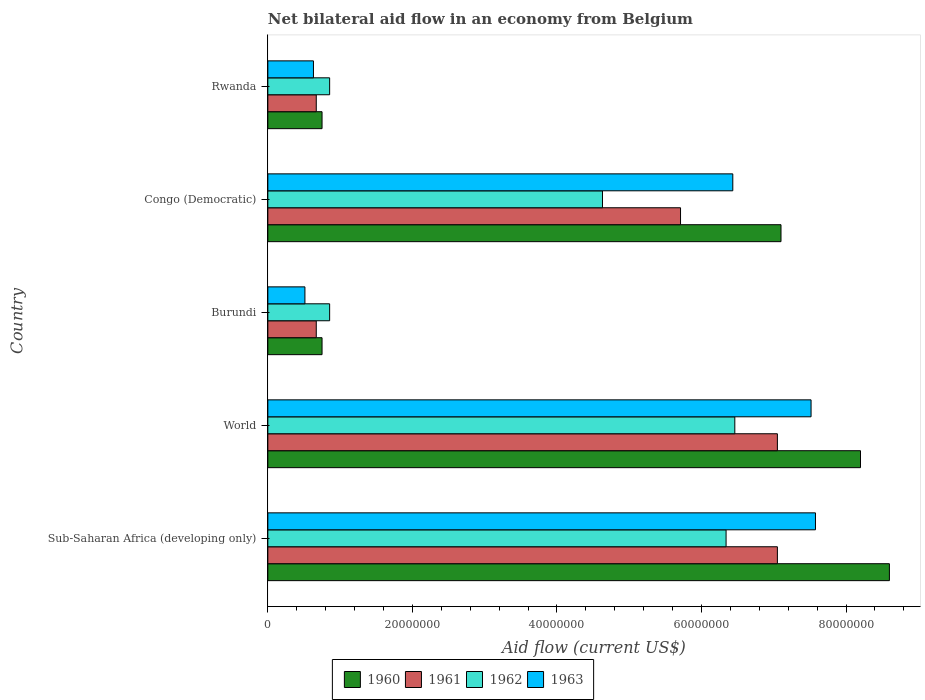How many different coloured bars are there?
Your answer should be compact. 4. How many groups of bars are there?
Keep it short and to the point. 5. How many bars are there on the 3rd tick from the top?
Your response must be concise. 4. How many bars are there on the 3rd tick from the bottom?
Provide a succinct answer. 4. What is the label of the 3rd group of bars from the top?
Your response must be concise. Burundi. In how many cases, is the number of bars for a given country not equal to the number of legend labels?
Your answer should be very brief. 0. What is the net bilateral aid flow in 1960 in Burundi?
Keep it short and to the point. 7.50e+06. Across all countries, what is the maximum net bilateral aid flow in 1961?
Keep it short and to the point. 7.05e+07. Across all countries, what is the minimum net bilateral aid flow in 1962?
Give a very brief answer. 8.55e+06. In which country was the net bilateral aid flow in 1963 maximum?
Your answer should be very brief. Sub-Saharan Africa (developing only). In which country was the net bilateral aid flow in 1961 minimum?
Keep it short and to the point. Burundi. What is the total net bilateral aid flow in 1963 in the graph?
Give a very brief answer. 2.27e+08. What is the difference between the net bilateral aid flow in 1961 in Congo (Democratic) and that in World?
Make the answer very short. -1.34e+07. What is the difference between the net bilateral aid flow in 1962 in Congo (Democratic) and the net bilateral aid flow in 1961 in World?
Make the answer very short. -2.42e+07. What is the average net bilateral aid flow in 1961 per country?
Ensure brevity in your answer.  4.23e+07. What is the difference between the net bilateral aid flow in 1962 and net bilateral aid flow in 1963 in World?
Make the answer very short. -1.06e+07. What is the ratio of the net bilateral aid flow in 1962 in Rwanda to that in World?
Offer a very short reply. 0.13. Is the net bilateral aid flow in 1961 in Burundi less than that in Congo (Democratic)?
Your response must be concise. Yes. Is the difference between the net bilateral aid flow in 1962 in Burundi and Sub-Saharan Africa (developing only) greater than the difference between the net bilateral aid flow in 1963 in Burundi and Sub-Saharan Africa (developing only)?
Ensure brevity in your answer.  Yes. What is the difference between the highest and the second highest net bilateral aid flow in 1960?
Offer a very short reply. 4.00e+06. What is the difference between the highest and the lowest net bilateral aid flow in 1960?
Provide a short and direct response. 7.85e+07. In how many countries, is the net bilateral aid flow in 1962 greater than the average net bilateral aid flow in 1962 taken over all countries?
Give a very brief answer. 3. Is it the case that in every country, the sum of the net bilateral aid flow in 1963 and net bilateral aid flow in 1960 is greater than the sum of net bilateral aid flow in 1961 and net bilateral aid flow in 1962?
Offer a terse response. No. What does the 4th bar from the top in Rwanda represents?
Your answer should be very brief. 1960. Is it the case that in every country, the sum of the net bilateral aid flow in 1962 and net bilateral aid flow in 1960 is greater than the net bilateral aid flow in 1963?
Your answer should be compact. Yes. How many bars are there?
Provide a short and direct response. 20. What is the difference between two consecutive major ticks on the X-axis?
Give a very brief answer. 2.00e+07. Are the values on the major ticks of X-axis written in scientific E-notation?
Offer a very short reply. No. What is the title of the graph?
Keep it short and to the point. Net bilateral aid flow in an economy from Belgium. Does "2010" appear as one of the legend labels in the graph?
Offer a terse response. No. What is the label or title of the Y-axis?
Your answer should be compact. Country. What is the Aid flow (current US$) of 1960 in Sub-Saharan Africa (developing only)?
Make the answer very short. 8.60e+07. What is the Aid flow (current US$) in 1961 in Sub-Saharan Africa (developing only)?
Make the answer very short. 7.05e+07. What is the Aid flow (current US$) in 1962 in Sub-Saharan Africa (developing only)?
Provide a short and direct response. 6.34e+07. What is the Aid flow (current US$) of 1963 in Sub-Saharan Africa (developing only)?
Your answer should be very brief. 7.58e+07. What is the Aid flow (current US$) in 1960 in World?
Provide a succinct answer. 8.20e+07. What is the Aid flow (current US$) in 1961 in World?
Make the answer very short. 7.05e+07. What is the Aid flow (current US$) in 1962 in World?
Give a very brief answer. 6.46e+07. What is the Aid flow (current US$) in 1963 in World?
Provide a short and direct response. 7.52e+07. What is the Aid flow (current US$) in 1960 in Burundi?
Provide a short and direct response. 7.50e+06. What is the Aid flow (current US$) of 1961 in Burundi?
Your response must be concise. 6.70e+06. What is the Aid flow (current US$) in 1962 in Burundi?
Keep it short and to the point. 8.55e+06. What is the Aid flow (current US$) in 1963 in Burundi?
Ensure brevity in your answer.  5.13e+06. What is the Aid flow (current US$) in 1960 in Congo (Democratic)?
Your response must be concise. 7.10e+07. What is the Aid flow (current US$) of 1961 in Congo (Democratic)?
Your response must be concise. 5.71e+07. What is the Aid flow (current US$) in 1962 in Congo (Democratic)?
Provide a succinct answer. 4.63e+07. What is the Aid flow (current US$) in 1963 in Congo (Democratic)?
Offer a terse response. 6.43e+07. What is the Aid flow (current US$) in 1960 in Rwanda?
Provide a succinct answer. 7.50e+06. What is the Aid flow (current US$) in 1961 in Rwanda?
Provide a short and direct response. 6.70e+06. What is the Aid flow (current US$) of 1962 in Rwanda?
Your answer should be compact. 8.55e+06. What is the Aid flow (current US$) of 1963 in Rwanda?
Provide a short and direct response. 6.31e+06. Across all countries, what is the maximum Aid flow (current US$) of 1960?
Your answer should be compact. 8.60e+07. Across all countries, what is the maximum Aid flow (current US$) of 1961?
Offer a terse response. 7.05e+07. Across all countries, what is the maximum Aid flow (current US$) in 1962?
Your answer should be compact. 6.46e+07. Across all countries, what is the maximum Aid flow (current US$) in 1963?
Make the answer very short. 7.58e+07. Across all countries, what is the minimum Aid flow (current US$) in 1960?
Your answer should be very brief. 7.50e+06. Across all countries, what is the minimum Aid flow (current US$) in 1961?
Give a very brief answer. 6.70e+06. Across all countries, what is the minimum Aid flow (current US$) of 1962?
Ensure brevity in your answer.  8.55e+06. Across all countries, what is the minimum Aid flow (current US$) in 1963?
Your response must be concise. 5.13e+06. What is the total Aid flow (current US$) of 1960 in the graph?
Give a very brief answer. 2.54e+08. What is the total Aid flow (current US$) of 1961 in the graph?
Offer a very short reply. 2.12e+08. What is the total Aid flow (current US$) of 1962 in the graph?
Provide a succinct answer. 1.91e+08. What is the total Aid flow (current US$) in 1963 in the graph?
Your answer should be compact. 2.27e+08. What is the difference between the Aid flow (current US$) of 1960 in Sub-Saharan Africa (developing only) and that in World?
Your response must be concise. 4.00e+06. What is the difference between the Aid flow (current US$) in 1962 in Sub-Saharan Africa (developing only) and that in World?
Keep it short and to the point. -1.21e+06. What is the difference between the Aid flow (current US$) in 1963 in Sub-Saharan Africa (developing only) and that in World?
Ensure brevity in your answer.  6.10e+05. What is the difference between the Aid flow (current US$) in 1960 in Sub-Saharan Africa (developing only) and that in Burundi?
Give a very brief answer. 7.85e+07. What is the difference between the Aid flow (current US$) of 1961 in Sub-Saharan Africa (developing only) and that in Burundi?
Offer a terse response. 6.38e+07. What is the difference between the Aid flow (current US$) in 1962 in Sub-Saharan Africa (developing only) and that in Burundi?
Provide a succinct answer. 5.48e+07. What is the difference between the Aid flow (current US$) in 1963 in Sub-Saharan Africa (developing only) and that in Burundi?
Offer a very short reply. 7.06e+07. What is the difference between the Aid flow (current US$) in 1960 in Sub-Saharan Africa (developing only) and that in Congo (Democratic)?
Ensure brevity in your answer.  1.50e+07. What is the difference between the Aid flow (current US$) of 1961 in Sub-Saharan Africa (developing only) and that in Congo (Democratic)?
Provide a short and direct response. 1.34e+07. What is the difference between the Aid flow (current US$) of 1962 in Sub-Saharan Africa (developing only) and that in Congo (Democratic)?
Your answer should be very brief. 1.71e+07. What is the difference between the Aid flow (current US$) in 1963 in Sub-Saharan Africa (developing only) and that in Congo (Democratic)?
Your answer should be compact. 1.14e+07. What is the difference between the Aid flow (current US$) in 1960 in Sub-Saharan Africa (developing only) and that in Rwanda?
Offer a terse response. 7.85e+07. What is the difference between the Aid flow (current US$) of 1961 in Sub-Saharan Africa (developing only) and that in Rwanda?
Your answer should be compact. 6.38e+07. What is the difference between the Aid flow (current US$) in 1962 in Sub-Saharan Africa (developing only) and that in Rwanda?
Provide a short and direct response. 5.48e+07. What is the difference between the Aid flow (current US$) of 1963 in Sub-Saharan Africa (developing only) and that in Rwanda?
Ensure brevity in your answer.  6.95e+07. What is the difference between the Aid flow (current US$) in 1960 in World and that in Burundi?
Offer a terse response. 7.45e+07. What is the difference between the Aid flow (current US$) of 1961 in World and that in Burundi?
Give a very brief answer. 6.38e+07. What is the difference between the Aid flow (current US$) in 1962 in World and that in Burundi?
Keep it short and to the point. 5.61e+07. What is the difference between the Aid flow (current US$) in 1963 in World and that in Burundi?
Your response must be concise. 7.00e+07. What is the difference between the Aid flow (current US$) in 1960 in World and that in Congo (Democratic)?
Give a very brief answer. 1.10e+07. What is the difference between the Aid flow (current US$) of 1961 in World and that in Congo (Democratic)?
Make the answer very short. 1.34e+07. What is the difference between the Aid flow (current US$) in 1962 in World and that in Congo (Democratic)?
Offer a terse response. 1.83e+07. What is the difference between the Aid flow (current US$) of 1963 in World and that in Congo (Democratic)?
Make the answer very short. 1.08e+07. What is the difference between the Aid flow (current US$) of 1960 in World and that in Rwanda?
Your answer should be very brief. 7.45e+07. What is the difference between the Aid flow (current US$) in 1961 in World and that in Rwanda?
Ensure brevity in your answer.  6.38e+07. What is the difference between the Aid flow (current US$) of 1962 in World and that in Rwanda?
Keep it short and to the point. 5.61e+07. What is the difference between the Aid flow (current US$) in 1963 in World and that in Rwanda?
Offer a very short reply. 6.88e+07. What is the difference between the Aid flow (current US$) in 1960 in Burundi and that in Congo (Democratic)?
Your response must be concise. -6.35e+07. What is the difference between the Aid flow (current US$) of 1961 in Burundi and that in Congo (Democratic)?
Offer a terse response. -5.04e+07. What is the difference between the Aid flow (current US$) of 1962 in Burundi and that in Congo (Democratic)?
Provide a short and direct response. -3.78e+07. What is the difference between the Aid flow (current US$) in 1963 in Burundi and that in Congo (Democratic)?
Give a very brief answer. -5.92e+07. What is the difference between the Aid flow (current US$) of 1961 in Burundi and that in Rwanda?
Offer a very short reply. 0. What is the difference between the Aid flow (current US$) of 1963 in Burundi and that in Rwanda?
Your response must be concise. -1.18e+06. What is the difference between the Aid flow (current US$) in 1960 in Congo (Democratic) and that in Rwanda?
Offer a terse response. 6.35e+07. What is the difference between the Aid flow (current US$) in 1961 in Congo (Democratic) and that in Rwanda?
Offer a very short reply. 5.04e+07. What is the difference between the Aid flow (current US$) of 1962 in Congo (Democratic) and that in Rwanda?
Provide a short and direct response. 3.78e+07. What is the difference between the Aid flow (current US$) of 1963 in Congo (Democratic) and that in Rwanda?
Offer a very short reply. 5.80e+07. What is the difference between the Aid flow (current US$) of 1960 in Sub-Saharan Africa (developing only) and the Aid flow (current US$) of 1961 in World?
Make the answer very short. 1.55e+07. What is the difference between the Aid flow (current US$) in 1960 in Sub-Saharan Africa (developing only) and the Aid flow (current US$) in 1962 in World?
Your response must be concise. 2.14e+07. What is the difference between the Aid flow (current US$) in 1960 in Sub-Saharan Africa (developing only) and the Aid flow (current US$) in 1963 in World?
Your answer should be compact. 1.08e+07. What is the difference between the Aid flow (current US$) in 1961 in Sub-Saharan Africa (developing only) and the Aid flow (current US$) in 1962 in World?
Offer a terse response. 5.89e+06. What is the difference between the Aid flow (current US$) of 1961 in Sub-Saharan Africa (developing only) and the Aid flow (current US$) of 1963 in World?
Your answer should be compact. -4.66e+06. What is the difference between the Aid flow (current US$) in 1962 in Sub-Saharan Africa (developing only) and the Aid flow (current US$) in 1963 in World?
Your answer should be very brief. -1.18e+07. What is the difference between the Aid flow (current US$) of 1960 in Sub-Saharan Africa (developing only) and the Aid flow (current US$) of 1961 in Burundi?
Your answer should be compact. 7.93e+07. What is the difference between the Aid flow (current US$) of 1960 in Sub-Saharan Africa (developing only) and the Aid flow (current US$) of 1962 in Burundi?
Your response must be concise. 7.74e+07. What is the difference between the Aid flow (current US$) of 1960 in Sub-Saharan Africa (developing only) and the Aid flow (current US$) of 1963 in Burundi?
Keep it short and to the point. 8.09e+07. What is the difference between the Aid flow (current US$) in 1961 in Sub-Saharan Africa (developing only) and the Aid flow (current US$) in 1962 in Burundi?
Make the answer very short. 6.20e+07. What is the difference between the Aid flow (current US$) in 1961 in Sub-Saharan Africa (developing only) and the Aid flow (current US$) in 1963 in Burundi?
Offer a very short reply. 6.54e+07. What is the difference between the Aid flow (current US$) of 1962 in Sub-Saharan Africa (developing only) and the Aid flow (current US$) of 1963 in Burundi?
Offer a terse response. 5.83e+07. What is the difference between the Aid flow (current US$) of 1960 in Sub-Saharan Africa (developing only) and the Aid flow (current US$) of 1961 in Congo (Democratic)?
Offer a terse response. 2.89e+07. What is the difference between the Aid flow (current US$) of 1960 in Sub-Saharan Africa (developing only) and the Aid flow (current US$) of 1962 in Congo (Democratic)?
Your answer should be very brief. 3.97e+07. What is the difference between the Aid flow (current US$) in 1960 in Sub-Saharan Africa (developing only) and the Aid flow (current US$) in 1963 in Congo (Democratic)?
Keep it short and to the point. 2.17e+07. What is the difference between the Aid flow (current US$) in 1961 in Sub-Saharan Africa (developing only) and the Aid flow (current US$) in 1962 in Congo (Democratic)?
Offer a terse response. 2.42e+07. What is the difference between the Aid flow (current US$) in 1961 in Sub-Saharan Africa (developing only) and the Aid flow (current US$) in 1963 in Congo (Democratic)?
Make the answer very short. 6.17e+06. What is the difference between the Aid flow (current US$) in 1962 in Sub-Saharan Africa (developing only) and the Aid flow (current US$) in 1963 in Congo (Democratic)?
Offer a very short reply. -9.30e+05. What is the difference between the Aid flow (current US$) in 1960 in Sub-Saharan Africa (developing only) and the Aid flow (current US$) in 1961 in Rwanda?
Your response must be concise. 7.93e+07. What is the difference between the Aid flow (current US$) in 1960 in Sub-Saharan Africa (developing only) and the Aid flow (current US$) in 1962 in Rwanda?
Your answer should be compact. 7.74e+07. What is the difference between the Aid flow (current US$) in 1960 in Sub-Saharan Africa (developing only) and the Aid flow (current US$) in 1963 in Rwanda?
Your answer should be compact. 7.97e+07. What is the difference between the Aid flow (current US$) of 1961 in Sub-Saharan Africa (developing only) and the Aid flow (current US$) of 1962 in Rwanda?
Make the answer very short. 6.20e+07. What is the difference between the Aid flow (current US$) in 1961 in Sub-Saharan Africa (developing only) and the Aid flow (current US$) in 1963 in Rwanda?
Offer a terse response. 6.42e+07. What is the difference between the Aid flow (current US$) in 1962 in Sub-Saharan Africa (developing only) and the Aid flow (current US$) in 1963 in Rwanda?
Your answer should be compact. 5.71e+07. What is the difference between the Aid flow (current US$) of 1960 in World and the Aid flow (current US$) of 1961 in Burundi?
Your response must be concise. 7.53e+07. What is the difference between the Aid flow (current US$) in 1960 in World and the Aid flow (current US$) in 1962 in Burundi?
Provide a succinct answer. 7.34e+07. What is the difference between the Aid flow (current US$) of 1960 in World and the Aid flow (current US$) of 1963 in Burundi?
Keep it short and to the point. 7.69e+07. What is the difference between the Aid flow (current US$) of 1961 in World and the Aid flow (current US$) of 1962 in Burundi?
Offer a very short reply. 6.20e+07. What is the difference between the Aid flow (current US$) in 1961 in World and the Aid flow (current US$) in 1963 in Burundi?
Provide a short and direct response. 6.54e+07. What is the difference between the Aid flow (current US$) in 1962 in World and the Aid flow (current US$) in 1963 in Burundi?
Provide a succinct answer. 5.95e+07. What is the difference between the Aid flow (current US$) of 1960 in World and the Aid flow (current US$) of 1961 in Congo (Democratic)?
Offer a very short reply. 2.49e+07. What is the difference between the Aid flow (current US$) in 1960 in World and the Aid flow (current US$) in 1962 in Congo (Democratic)?
Ensure brevity in your answer.  3.57e+07. What is the difference between the Aid flow (current US$) of 1960 in World and the Aid flow (current US$) of 1963 in Congo (Democratic)?
Ensure brevity in your answer.  1.77e+07. What is the difference between the Aid flow (current US$) of 1961 in World and the Aid flow (current US$) of 1962 in Congo (Democratic)?
Ensure brevity in your answer.  2.42e+07. What is the difference between the Aid flow (current US$) in 1961 in World and the Aid flow (current US$) in 1963 in Congo (Democratic)?
Give a very brief answer. 6.17e+06. What is the difference between the Aid flow (current US$) of 1960 in World and the Aid flow (current US$) of 1961 in Rwanda?
Keep it short and to the point. 7.53e+07. What is the difference between the Aid flow (current US$) in 1960 in World and the Aid flow (current US$) in 1962 in Rwanda?
Your answer should be very brief. 7.34e+07. What is the difference between the Aid flow (current US$) in 1960 in World and the Aid flow (current US$) in 1963 in Rwanda?
Make the answer very short. 7.57e+07. What is the difference between the Aid flow (current US$) of 1961 in World and the Aid flow (current US$) of 1962 in Rwanda?
Make the answer very short. 6.20e+07. What is the difference between the Aid flow (current US$) of 1961 in World and the Aid flow (current US$) of 1963 in Rwanda?
Offer a very short reply. 6.42e+07. What is the difference between the Aid flow (current US$) of 1962 in World and the Aid flow (current US$) of 1963 in Rwanda?
Give a very brief answer. 5.83e+07. What is the difference between the Aid flow (current US$) of 1960 in Burundi and the Aid flow (current US$) of 1961 in Congo (Democratic)?
Ensure brevity in your answer.  -4.96e+07. What is the difference between the Aid flow (current US$) in 1960 in Burundi and the Aid flow (current US$) in 1962 in Congo (Democratic)?
Give a very brief answer. -3.88e+07. What is the difference between the Aid flow (current US$) of 1960 in Burundi and the Aid flow (current US$) of 1963 in Congo (Democratic)?
Ensure brevity in your answer.  -5.68e+07. What is the difference between the Aid flow (current US$) in 1961 in Burundi and the Aid flow (current US$) in 1962 in Congo (Democratic)?
Your answer should be very brief. -3.96e+07. What is the difference between the Aid flow (current US$) in 1961 in Burundi and the Aid flow (current US$) in 1963 in Congo (Democratic)?
Offer a terse response. -5.76e+07. What is the difference between the Aid flow (current US$) of 1962 in Burundi and the Aid flow (current US$) of 1963 in Congo (Democratic)?
Your answer should be very brief. -5.58e+07. What is the difference between the Aid flow (current US$) in 1960 in Burundi and the Aid flow (current US$) in 1961 in Rwanda?
Offer a terse response. 8.00e+05. What is the difference between the Aid flow (current US$) of 1960 in Burundi and the Aid flow (current US$) of 1962 in Rwanda?
Offer a very short reply. -1.05e+06. What is the difference between the Aid flow (current US$) of 1960 in Burundi and the Aid flow (current US$) of 1963 in Rwanda?
Ensure brevity in your answer.  1.19e+06. What is the difference between the Aid flow (current US$) of 1961 in Burundi and the Aid flow (current US$) of 1962 in Rwanda?
Give a very brief answer. -1.85e+06. What is the difference between the Aid flow (current US$) in 1962 in Burundi and the Aid flow (current US$) in 1963 in Rwanda?
Your answer should be very brief. 2.24e+06. What is the difference between the Aid flow (current US$) in 1960 in Congo (Democratic) and the Aid flow (current US$) in 1961 in Rwanda?
Keep it short and to the point. 6.43e+07. What is the difference between the Aid flow (current US$) of 1960 in Congo (Democratic) and the Aid flow (current US$) of 1962 in Rwanda?
Your answer should be compact. 6.24e+07. What is the difference between the Aid flow (current US$) in 1960 in Congo (Democratic) and the Aid flow (current US$) in 1963 in Rwanda?
Your answer should be compact. 6.47e+07. What is the difference between the Aid flow (current US$) in 1961 in Congo (Democratic) and the Aid flow (current US$) in 1962 in Rwanda?
Your answer should be compact. 4.86e+07. What is the difference between the Aid flow (current US$) in 1961 in Congo (Democratic) and the Aid flow (current US$) in 1963 in Rwanda?
Your response must be concise. 5.08e+07. What is the difference between the Aid flow (current US$) of 1962 in Congo (Democratic) and the Aid flow (current US$) of 1963 in Rwanda?
Your answer should be compact. 4.00e+07. What is the average Aid flow (current US$) of 1960 per country?
Your answer should be very brief. 5.08e+07. What is the average Aid flow (current US$) of 1961 per country?
Give a very brief answer. 4.23e+07. What is the average Aid flow (current US$) in 1962 per country?
Offer a terse response. 3.83e+07. What is the average Aid flow (current US$) in 1963 per country?
Ensure brevity in your answer.  4.53e+07. What is the difference between the Aid flow (current US$) in 1960 and Aid flow (current US$) in 1961 in Sub-Saharan Africa (developing only)?
Your response must be concise. 1.55e+07. What is the difference between the Aid flow (current US$) of 1960 and Aid flow (current US$) of 1962 in Sub-Saharan Africa (developing only)?
Provide a succinct answer. 2.26e+07. What is the difference between the Aid flow (current US$) of 1960 and Aid flow (current US$) of 1963 in Sub-Saharan Africa (developing only)?
Your response must be concise. 1.02e+07. What is the difference between the Aid flow (current US$) of 1961 and Aid flow (current US$) of 1962 in Sub-Saharan Africa (developing only)?
Your answer should be very brief. 7.10e+06. What is the difference between the Aid flow (current US$) in 1961 and Aid flow (current US$) in 1963 in Sub-Saharan Africa (developing only)?
Give a very brief answer. -5.27e+06. What is the difference between the Aid flow (current US$) of 1962 and Aid flow (current US$) of 1963 in Sub-Saharan Africa (developing only)?
Your answer should be compact. -1.24e+07. What is the difference between the Aid flow (current US$) in 1960 and Aid flow (current US$) in 1961 in World?
Offer a very short reply. 1.15e+07. What is the difference between the Aid flow (current US$) in 1960 and Aid flow (current US$) in 1962 in World?
Ensure brevity in your answer.  1.74e+07. What is the difference between the Aid flow (current US$) of 1960 and Aid flow (current US$) of 1963 in World?
Make the answer very short. 6.84e+06. What is the difference between the Aid flow (current US$) in 1961 and Aid flow (current US$) in 1962 in World?
Make the answer very short. 5.89e+06. What is the difference between the Aid flow (current US$) in 1961 and Aid flow (current US$) in 1963 in World?
Your answer should be very brief. -4.66e+06. What is the difference between the Aid flow (current US$) of 1962 and Aid flow (current US$) of 1963 in World?
Provide a succinct answer. -1.06e+07. What is the difference between the Aid flow (current US$) in 1960 and Aid flow (current US$) in 1961 in Burundi?
Give a very brief answer. 8.00e+05. What is the difference between the Aid flow (current US$) in 1960 and Aid flow (current US$) in 1962 in Burundi?
Provide a succinct answer. -1.05e+06. What is the difference between the Aid flow (current US$) of 1960 and Aid flow (current US$) of 1963 in Burundi?
Make the answer very short. 2.37e+06. What is the difference between the Aid flow (current US$) in 1961 and Aid flow (current US$) in 1962 in Burundi?
Give a very brief answer. -1.85e+06. What is the difference between the Aid flow (current US$) of 1961 and Aid flow (current US$) of 1963 in Burundi?
Offer a very short reply. 1.57e+06. What is the difference between the Aid flow (current US$) of 1962 and Aid flow (current US$) of 1963 in Burundi?
Offer a terse response. 3.42e+06. What is the difference between the Aid flow (current US$) of 1960 and Aid flow (current US$) of 1961 in Congo (Democratic)?
Provide a succinct answer. 1.39e+07. What is the difference between the Aid flow (current US$) of 1960 and Aid flow (current US$) of 1962 in Congo (Democratic)?
Offer a very short reply. 2.47e+07. What is the difference between the Aid flow (current US$) in 1960 and Aid flow (current US$) in 1963 in Congo (Democratic)?
Your response must be concise. 6.67e+06. What is the difference between the Aid flow (current US$) of 1961 and Aid flow (current US$) of 1962 in Congo (Democratic)?
Offer a very short reply. 1.08e+07. What is the difference between the Aid flow (current US$) of 1961 and Aid flow (current US$) of 1963 in Congo (Democratic)?
Offer a terse response. -7.23e+06. What is the difference between the Aid flow (current US$) in 1962 and Aid flow (current US$) in 1963 in Congo (Democratic)?
Offer a terse response. -1.80e+07. What is the difference between the Aid flow (current US$) of 1960 and Aid flow (current US$) of 1961 in Rwanda?
Provide a short and direct response. 8.00e+05. What is the difference between the Aid flow (current US$) of 1960 and Aid flow (current US$) of 1962 in Rwanda?
Your answer should be compact. -1.05e+06. What is the difference between the Aid flow (current US$) of 1960 and Aid flow (current US$) of 1963 in Rwanda?
Your answer should be compact. 1.19e+06. What is the difference between the Aid flow (current US$) in 1961 and Aid flow (current US$) in 1962 in Rwanda?
Provide a succinct answer. -1.85e+06. What is the difference between the Aid flow (current US$) in 1961 and Aid flow (current US$) in 1963 in Rwanda?
Your answer should be compact. 3.90e+05. What is the difference between the Aid flow (current US$) in 1962 and Aid flow (current US$) in 1963 in Rwanda?
Provide a succinct answer. 2.24e+06. What is the ratio of the Aid flow (current US$) of 1960 in Sub-Saharan Africa (developing only) to that in World?
Give a very brief answer. 1.05. What is the ratio of the Aid flow (current US$) of 1962 in Sub-Saharan Africa (developing only) to that in World?
Your answer should be compact. 0.98. What is the ratio of the Aid flow (current US$) of 1960 in Sub-Saharan Africa (developing only) to that in Burundi?
Your answer should be very brief. 11.47. What is the ratio of the Aid flow (current US$) in 1961 in Sub-Saharan Africa (developing only) to that in Burundi?
Offer a very short reply. 10.52. What is the ratio of the Aid flow (current US$) in 1962 in Sub-Saharan Africa (developing only) to that in Burundi?
Provide a short and direct response. 7.42. What is the ratio of the Aid flow (current US$) of 1963 in Sub-Saharan Africa (developing only) to that in Burundi?
Provide a short and direct response. 14.77. What is the ratio of the Aid flow (current US$) of 1960 in Sub-Saharan Africa (developing only) to that in Congo (Democratic)?
Your response must be concise. 1.21. What is the ratio of the Aid flow (current US$) of 1961 in Sub-Saharan Africa (developing only) to that in Congo (Democratic)?
Offer a very short reply. 1.23. What is the ratio of the Aid flow (current US$) in 1962 in Sub-Saharan Africa (developing only) to that in Congo (Democratic)?
Your response must be concise. 1.37. What is the ratio of the Aid flow (current US$) in 1963 in Sub-Saharan Africa (developing only) to that in Congo (Democratic)?
Offer a terse response. 1.18. What is the ratio of the Aid flow (current US$) in 1960 in Sub-Saharan Africa (developing only) to that in Rwanda?
Ensure brevity in your answer.  11.47. What is the ratio of the Aid flow (current US$) in 1961 in Sub-Saharan Africa (developing only) to that in Rwanda?
Make the answer very short. 10.52. What is the ratio of the Aid flow (current US$) of 1962 in Sub-Saharan Africa (developing only) to that in Rwanda?
Offer a terse response. 7.42. What is the ratio of the Aid flow (current US$) in 1963 in Sub-Saharan Africa (developing only) to that in Rwanda?
Provide a short and direct response. 12.01. What is the ratio of the Aid flow (current US$) in 1960 in World to that in Burundi?
Your answer should be very brief. 10.93. What is the ratio of the Aid flow (current US$) of 1961 in World to that in Burundi?
Give a very brief answer. 10.52. What is the ratio of the Aid flow (current US$) of 1962 in World to that in Burundi?
Offer a very short reply. 7.56. What is the ratio of the Aid flow (current US$) of 1963 in World to that in Burundi?
Your response must be concise. 14.65. What is the ratio of the Aid flow (current US$) of 1960 in World to that in Congo (Democratic)?
Your response must be concise. 1.15. What is the ratio of the Aid flow (current US$) of 1961 in World to that in Congo (Democratic)?
Make the answer very short. 1.23. What is the ratio of the Aid flow (current US$) of 1962 in World to that in Congo (Democratic)?
Offer a terse response. 1.4. What is the ratio of the Aid flow (current US$) in 1963 in World to that in Congo (Democratic)?
Keep it short and to the point. 1.17. What is the ratio of the Aid flow (current US$) of 1960 in World to that in Rwanda?
Keep it short and to the point. 10.93. What is the ratio of the Aid flow (current US$) in 1961 in World to that in Rwanda?
Ensure brevity in your answer.  10.52. What is the ratio of the Aid flow (current US$) in 1962 in World to that in Rwanda?
Offer a very short reply. 7.56. What is the ratio of the Aid flow (current US$) of 1963 in World to that in Rwanda?
Your response must be concise. 11.91. What is the ratio of the Aid flow (current US$) of 1960 in Burundi to that in Congo (Democratic)?
Keep it short and to the point. 0.11. What is the ratio of the Aid flow (current US$) of 1961 in Burundi to that in Congo (Democratic)?
Your answer should be compact. 0.12. What is the ratio of the Aid flow (current US$) of 1962 in Burundi to that in Congo (Democratic)?
Provide a short and direct response. 0.18. What is the ratio of the Aid flow (current US$) of 1963 in Burundi to that in Congo (Democratic)?
Give a very brief answer. 0.08. What is the ratio of the Aid flow (current US$) in 1961 in Burundi to that in Rwanda?
Provide a succinct answer. 1. What is the ratio of the Aid flow (current US$) of 1962 in Burundi to that in Rwanda?
Provide a short and direct response. 1. What is the ratio of the Aid flow (current US$) of 1963 in Burundi to that in Rwanda?
Your answer should be compact. 0.81. What is the ratio of the Aid flow (current US$) of 1960 in Congo (Democratic) to that in Rwanda?
Your answer should be compact. 9.47. What is the ratio of the Aid flow (current US$) of 1961 in Congo (Democratic) to that in Rwanda?
Offer a very short reply. 8.52. What is the ratio of the Aid flow (current US$) in 1962 in Congo (Democratic) to that in Rwanda?
Keep it short and to the point. 5.42. What is the ratio of the Aid flow (current US$) in 1963 in Congo (Democratic) to that in Rwanda?
Your response must be concise. 10.19. What is the difference between the highest and the second highest Aid flow (current US$) in 1960?
Give a very brief answer. 4.00e+06. What is the difference between the highest and the second highest Aid flow (current US$) of 1961?
Ensure brevity in your answer.  0. What is the difference between the highest and the second highest Aid flow (current US$) of 1962?
Your response must be concise. 1.21e+06. What is the difference between the highest and the lowest Aid flow (current US$) in 1960?
Ensure brevity in your answer.  7.85e+07. What is the difference between the highest and the lowest Aid flow (current US$) of 1961?
Offer a terse response. 6.38e+07. What is the difference between the highest and the lowest Aid flow (current US$) in 1962?
Offer a terse response. 5.61e+07. What is the difference between the highest and the lowest Aid flow (current US$) of 1963?
Provide a succinct answer. 7.06e+07. 